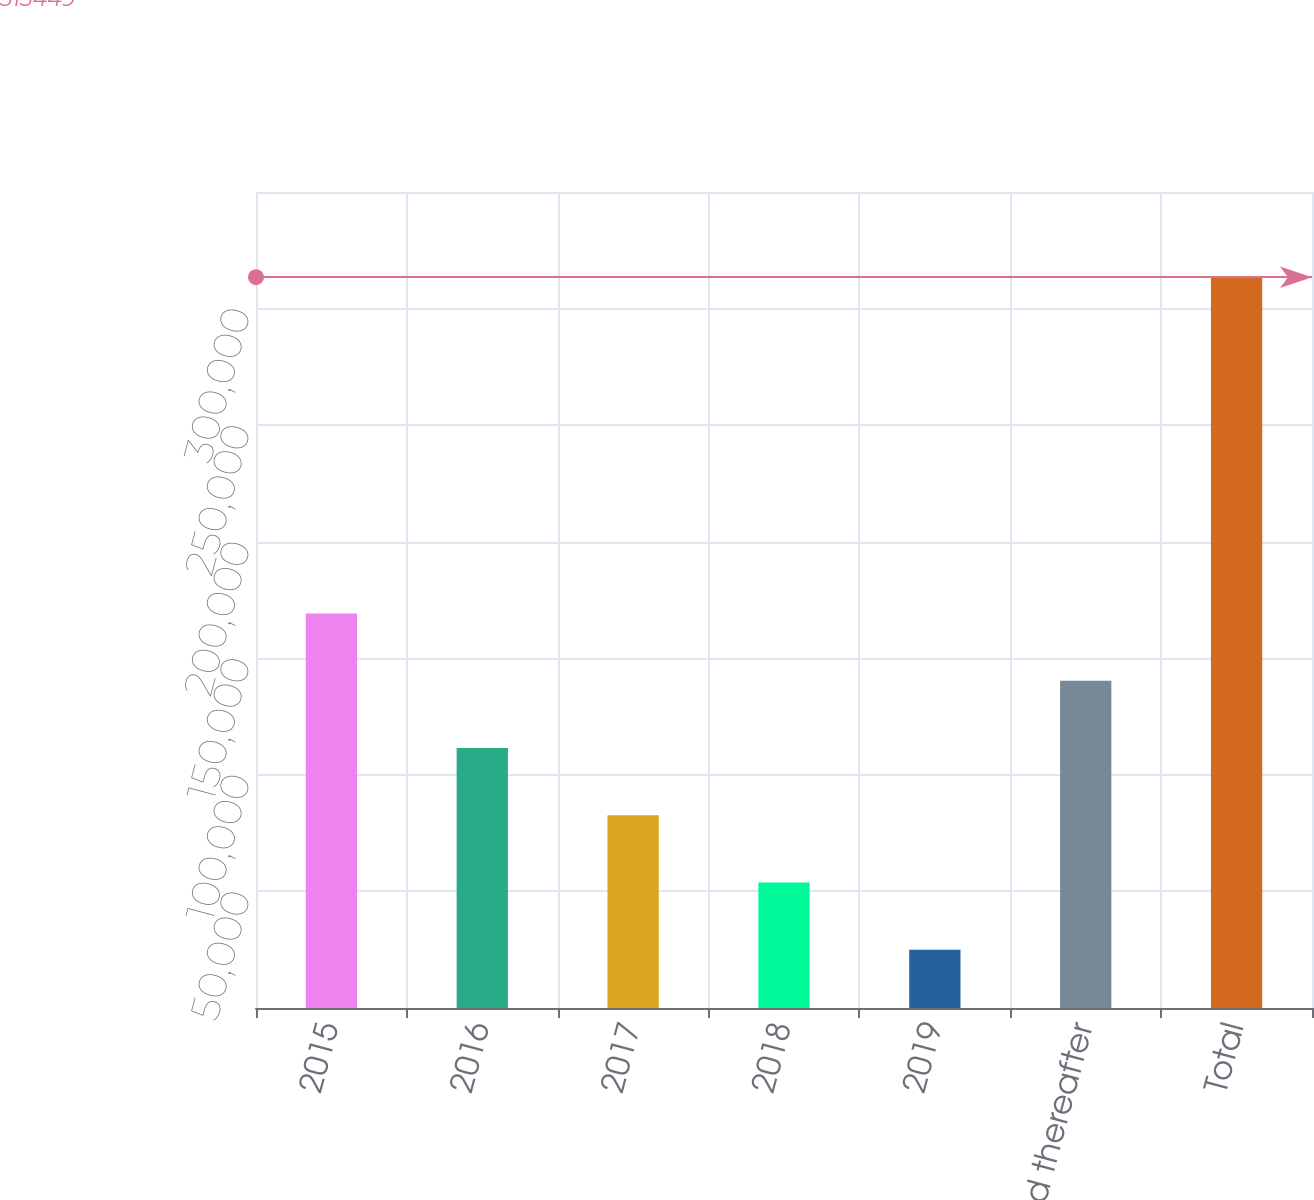<chart> <loc_0><loc_0><loc_500><loc_500><bar_chart><fcel>2015<fcel>2016<fcel>2017<fcel>2018<fcel>2019<fcel>2020 and thereafter<fcel>Total<nl><fcel>169223<fcel>111533<fcel>82687.4<fcel>53842.2<fcel>24997<fcel>140378<fcel>313449<nl></chart> 